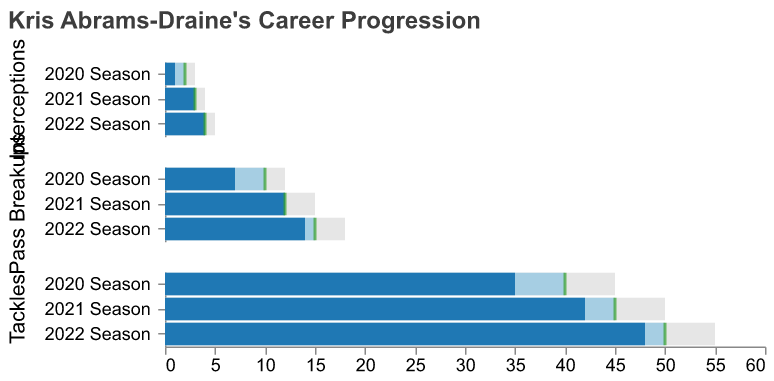What is the title of the figure? The title of the figure is displayed at the top and summarizes the main topic of the chart. It says "Kris Abrams-Draine's Career Progression".
Answer: Kris Abrams-Draine's Career Progression How many interceptions did Kris Abrams-Draine achieve in the 2020 season? Locate the "Interceptions" category for the "2020 Season" and check the "Actual" value, which shows how many interceptions he recorded in that year.
Answer: 1 Did Kris Abrams-Draine meet his goal for pass breakups in the 2021 season? Look at the "Pass Breakups" category for the "2021 Season". Compare the "Actual" value (12) with the "Goal" value (12). Since they are equal, he met his goal.
Answer: Yes Which season did Kris achieve the highest number of tackles, and what was the value? Compare the "Actual" values in the "Tackles" category across all seasons (2020, 2021, 2022) to determine the highest value. The highest number of tackles (48) was in the "2022 Season".
Answer: 2022 Season, 48 How many more pass breakups did Kris achieve in the 2022 season compared to the 2020 season? Subtract the "Actual" value of pass breakups in the 2020 season (7) from the "Actual" value in the 2022 season (14). This calculation shows how the number of pass breakups increased. 14 - 7 = 7
Answer: 7 By how much did Kris exceed his interception goal in the 2022 season? Find the "Interceptions" category for the "2022 Season". Subtract the "Goal" value (4) from the "Actual" value (4) to determine the difference. Since the goal and actual are equal, he did not exceed his goal.
Answer: 0 What is the trend in the number of tackles over the years 2020 to 2022? Analyze the "Actual" values in the "Tackles" category for each season: 35 (2020), 42 (2021), and 48 (2022). The trend shows a steady increase in the number of tackles each year.
Answer: Increasing Did Kris achieve any of his goals in the "Interceptions" category in any of the seasons covered? Review the "Interceptions" values for each season. For 2020, the "Actual" (1) is less than the "Goal" (2); for 2021, the "Actual" (3) equals the "Goal" (3); for 2022, the "Actual" (4) equals the "Goal" (4). He met his goal during 2021 and 2022 seasons.
Answer: Yes, in 2021 and 2022 Compare Kris's actual performance in tackles to the comparative value in the 2021 season. Was it higher or lower? In the "Tackles" category for the "2021 Season", compare the "Actual" value (42) with the "Comparative" value (50). The actual value is lower than the comparative value.
Answer: Lower What percentage of his goal did Kris achieve in interceptions in the 2020 season? Find the "Actual" and "Goal" values for the "Interceptions" category in the "2020 Season". Calculate the percentage as (Actual/Goal) * 100. (1/2) * 100 = 50%.
Answer: 50% 